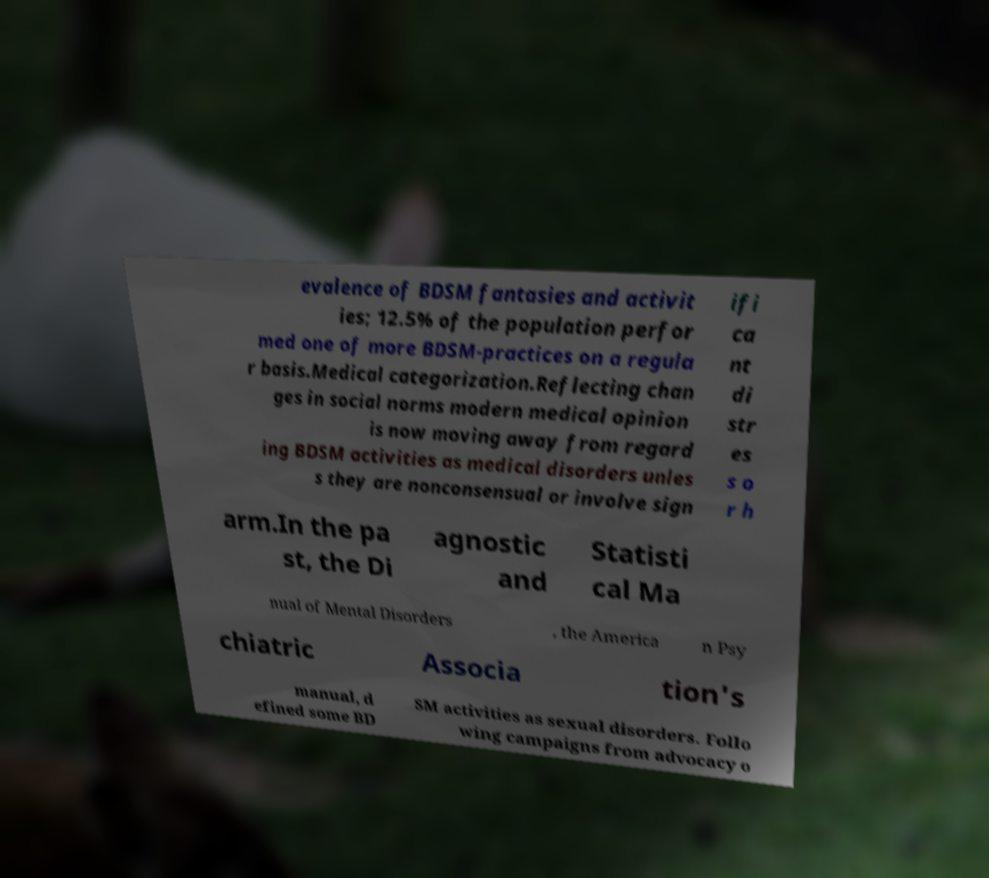Can you accurately transcribe the text from the provided image for me? evalence of BDSM fantasies and activit ies; 12.5% of the population perfor med one of more BDSM-practices on a regula r basis.Medical categorization.Reflecting chan ges in social norms modern medical opinion is now moving away from regard ing BDSM activities as medical disorders unles s they are nonconsensual or involve sign ifi ca nt di str es s o r h arm.In the pa st, the Di agnostic and Statisti cal Ma nual of Mental Disorders , the America n Psy chiatric Associa tion's manual, d efined some BD SM activities as sexual disorders. Follo wing campaigns from advocacy o 